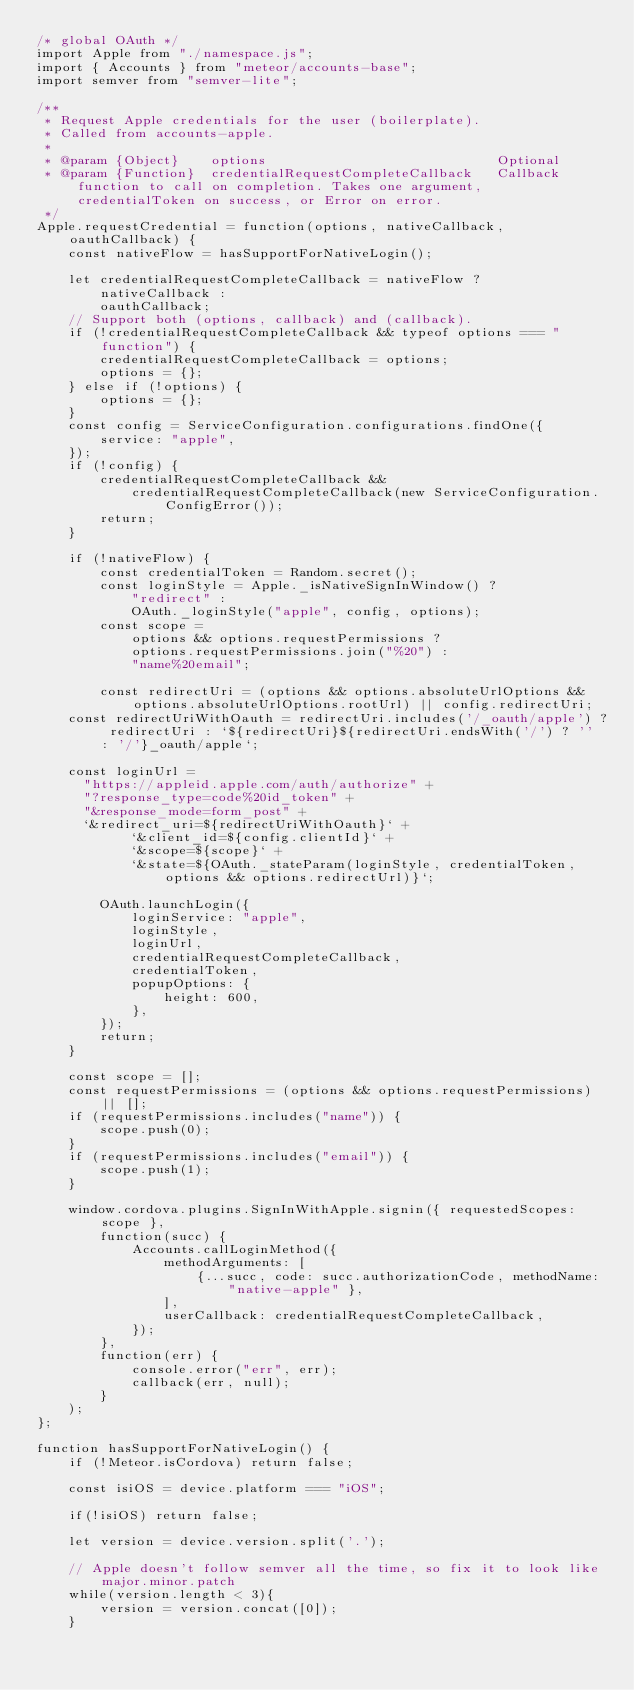Convert code to text. <code><loc_0><loc_0><loc_500><loc_500><_JavaScript_>/* global OAuth */
import Apple from "./namespace.js";
import { Accounts } from "meteor/accounts-base";
import semver from "semver-lite";

/**
 * Request Apple credentials for the user (boilerplate).
 * Called from accounts-apple.
 *
 * @param {Object}    options                             Optional
 * @param {Function}  credentialRequestCompleteCallback   Callback function to call on completion. Takes one argument, credentialToken on success, or Error on error.
 */
Apple.requestCredential = function(options, nativeCallback, oauthCallback) {
    const nativeFlow = hasSupportForNativeLogin();

    let credentialRequestCompleteCallback = nativeFlow ?
        nativeCallback :
        oauthCallback;
    // Support both (options, callback) and (callback).
    if (!credentialRequestCompleteCallback && typeof options === "function") {
        credentialRequestCompleteCallback = options;
        options = {};
    } else if (!options) {
        options = {};
    }
    const config = ServiceConfiguration.configurations.findOne({
        service: "apple",
    });
    if (!config) {
        credentialRequestCompleteCallback &&
            credentialRequestCompleteCallback(new ServiceConfiguration.ConfigError());
        return;
    }

    if (!nativeFlow) {
        const credentialToken = Random.secret();
        const loginStyle = Apple._isNativeSignInWindow() ?
            "redirect" :
            OAuth._loginStyle("apple", config, options);
        const scope =
            options && options.requestPermissions ?
            options.requestPermissions.join("%20") :
            "name%20email";

        const redirectUri = (options && options.absoluteUrlOptions && options.absoluteUrlOptions.rootUrl) || config.redirectUri;
    const redirectUriWithOauth = redirectUri.includes('/_oauth/apple') ? redirectUri : `${redirectUri}${redirectUri.endsWith('/') ? '' : '/'}_oauth/apple`;

    const loginUrl =
      "https://appleid.apple.com/auth/authorize" +
      "?response_type=code%20id_token" +
      "&response_mode=form_post" +
      `&redirect_uri=${redirectUriWithOauth}` +
            `&client_id=${config.clientId}` +
            `&scope=${scope}` +
            `&state=${OAuth._stateParam(loginStyle, credentialToken, options && options.redirectUrl)}`;

        OAuth.launchLogin({
            loginService: "apple",
            loginStyle,
            loginUrl,
            credentialRequestCompleteCallback,
            credentialToken,
            popupOptions: {
                height: 600,
            },
        });
        return;
    }

    const scope = [];
    const requestPermissions = (options && options.requestPermissions) || [];
    if (requestPermissions.includes("name")) {
        scope.push(0);
    }
    if (requestPermissions.includes("email")) {
        scope.push(1);
    }

    window.cordova.plugins.SignInWithApple.signin({ requestedScopes: scope },
        function(succ) {
            Accounts.callLoginMethod({
                methodArguments: [
                    {...succ, code: succ.authorizationCode, methodName: "native-apple" },
                ],
                userCallback: credentialRequestCompleteCallback,
            });
        },
        function(err) {
            console.error("err", err);
            callback(err, null);
        }
    );
};

function hasSupportForNativeLogin() {
    if (!Meteor.isCordova) return false;

    const isiOS = device.platform === "iOS";

    if(!isiOS) return false;

    let version = device.version.split('.');

    // Apple doesn't follow semver all the time, so fix it to look like major.minor.patch
    while(version.length < 3){
        version = version.concat([0]);
    }</code> 